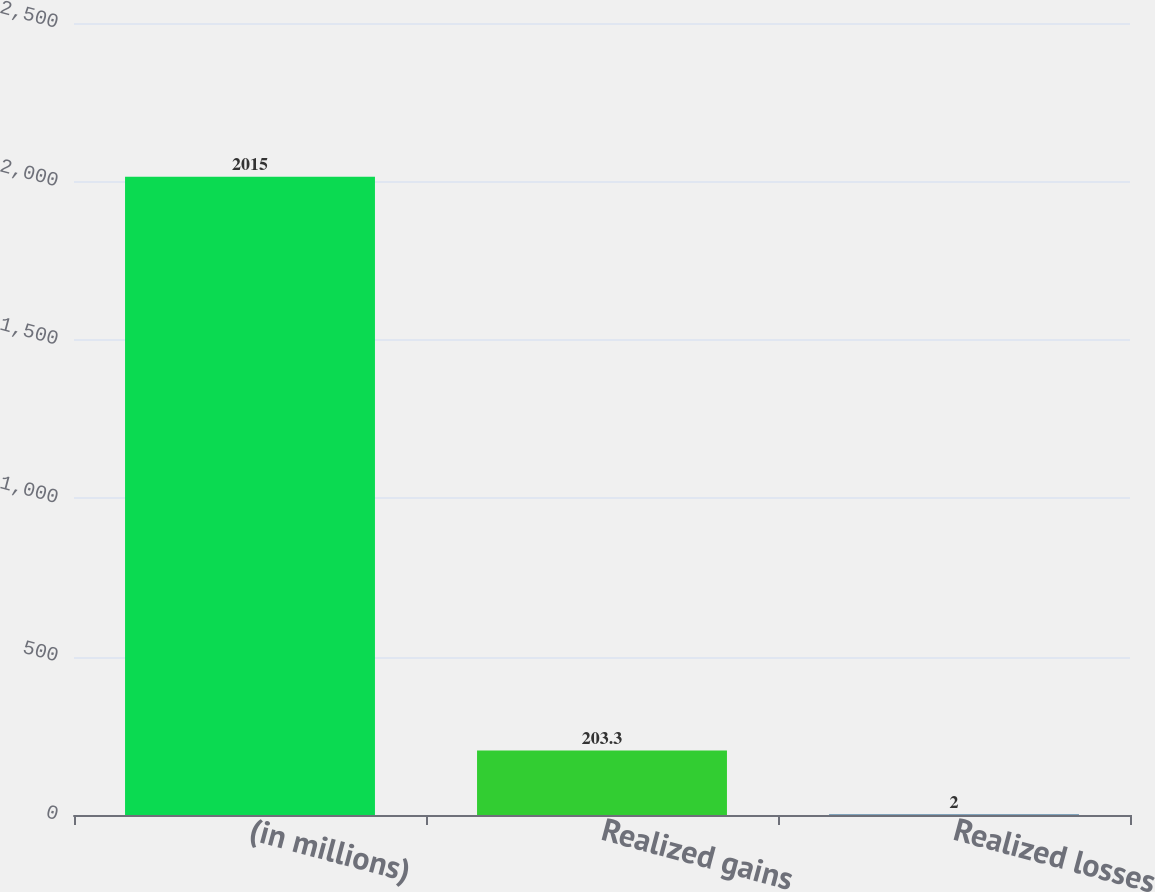<chart> <loc_0><loc_0><loc_500><loc_500><bar_chart><fcel>(in millions)<fcel>Realized gains<fcel>Realized losses<nl><fcel>2015<fcel>203.3<fcel>2<nl></chart> 